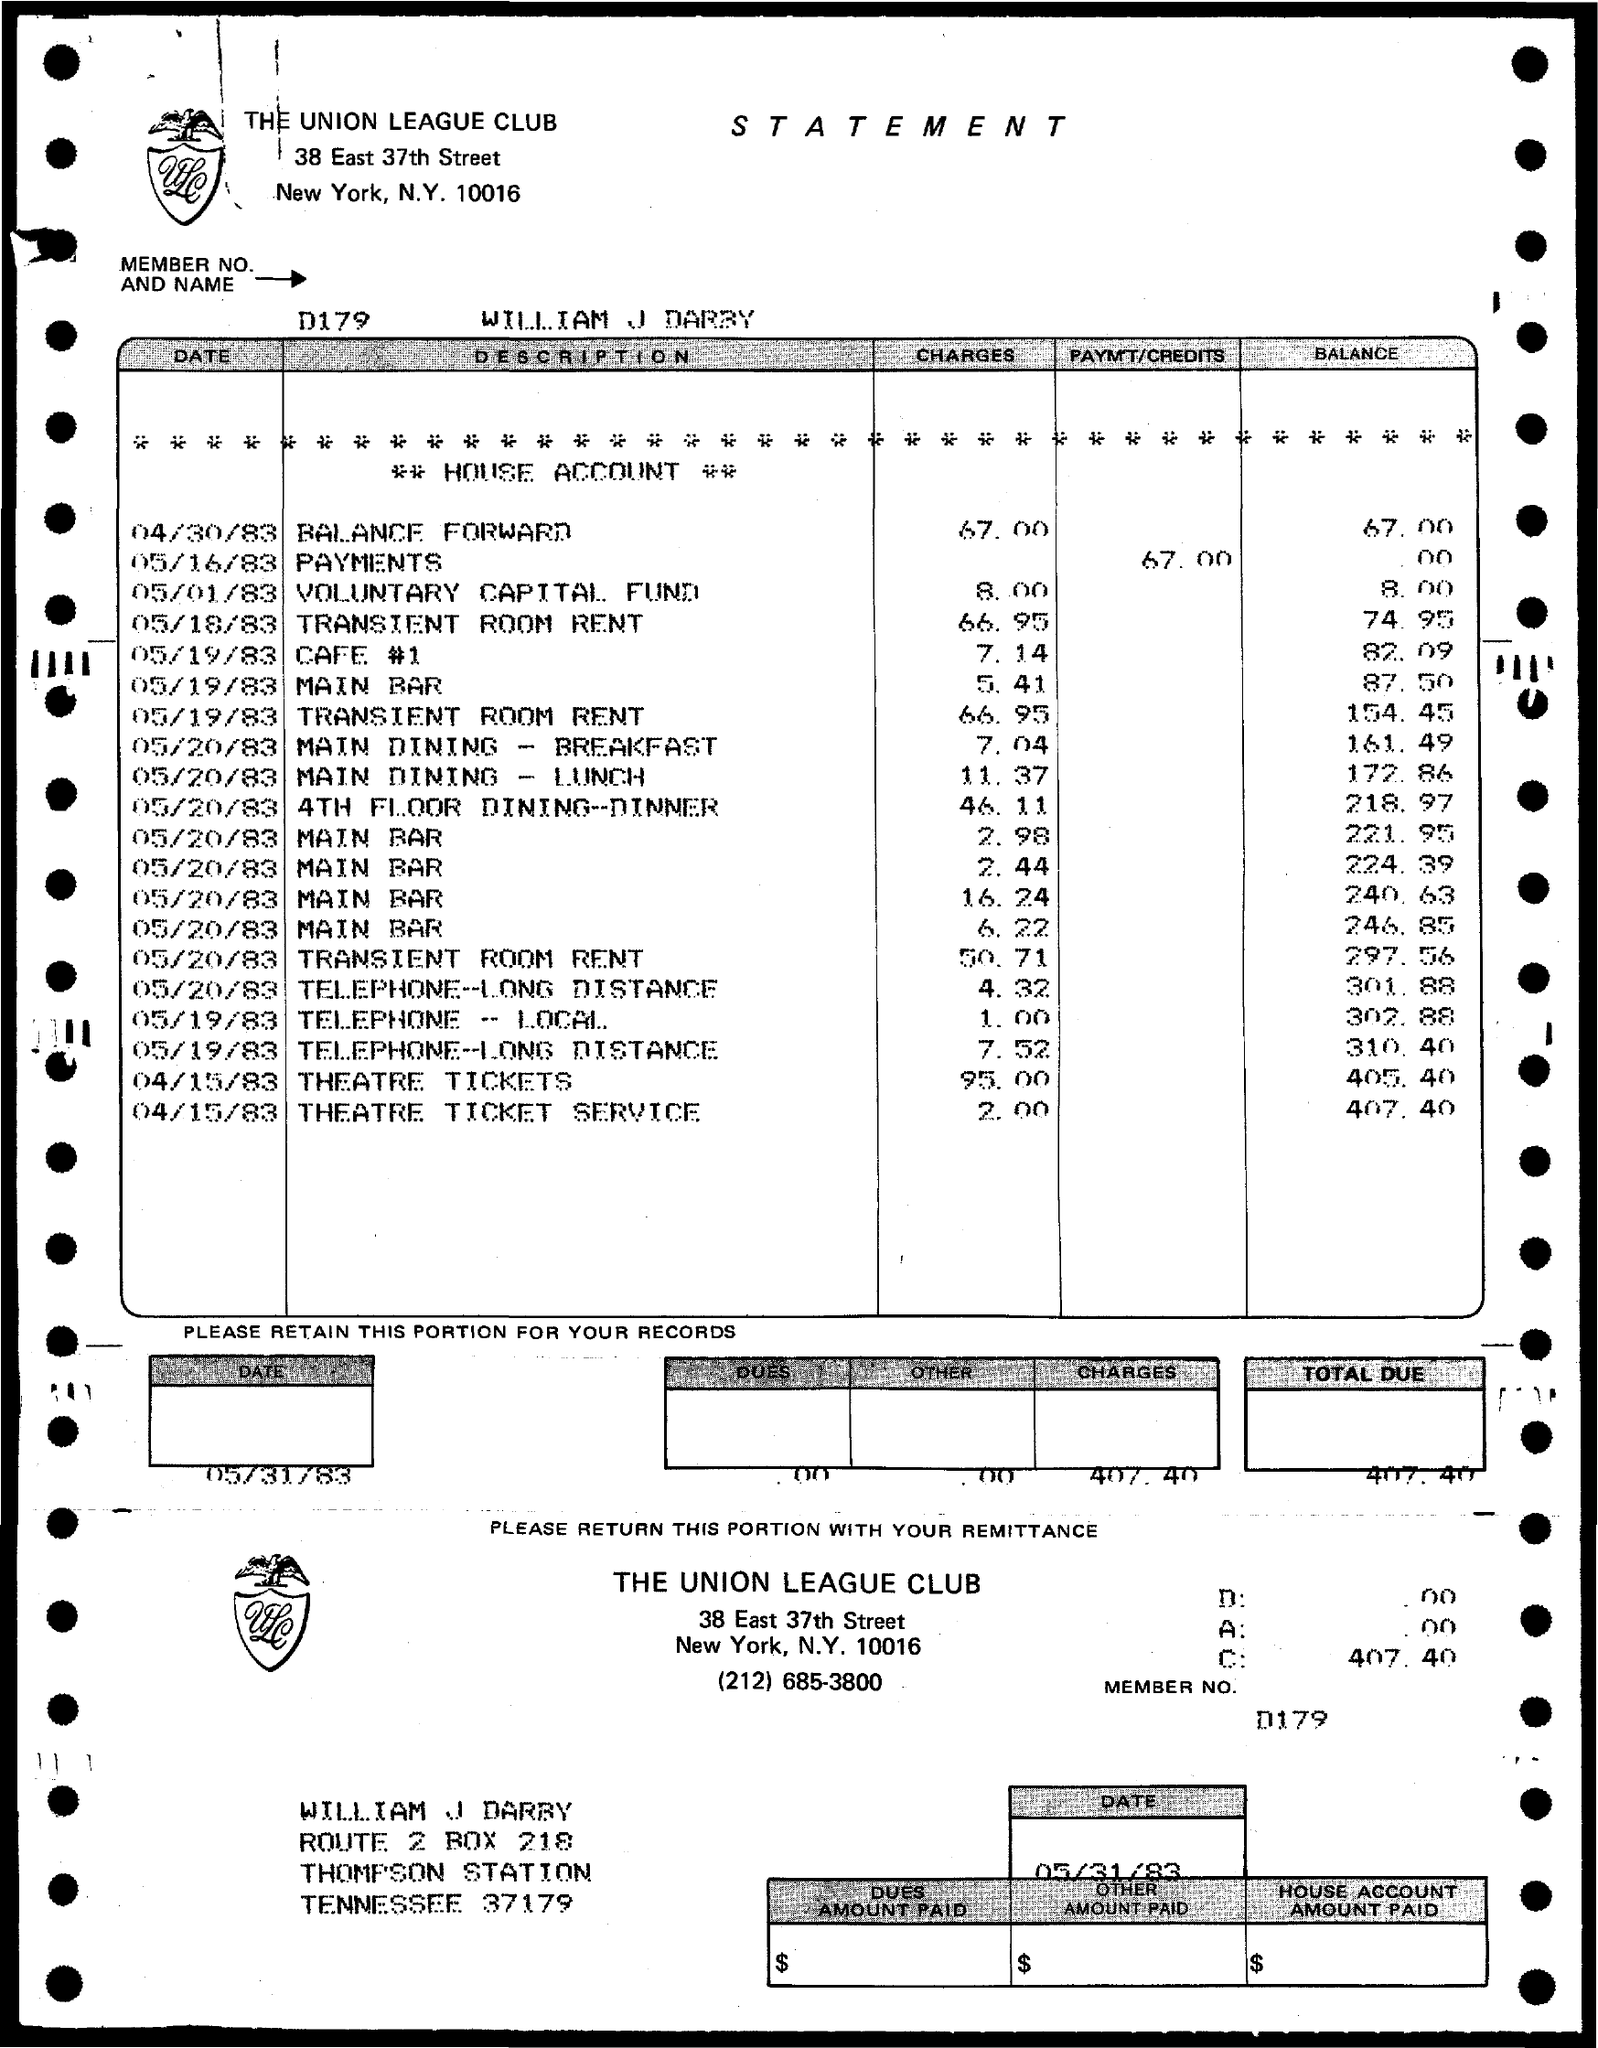What is the member number?
Provide a short and direct response. D179. What is the name of the member?
Your response must be concise. William J Darby. 